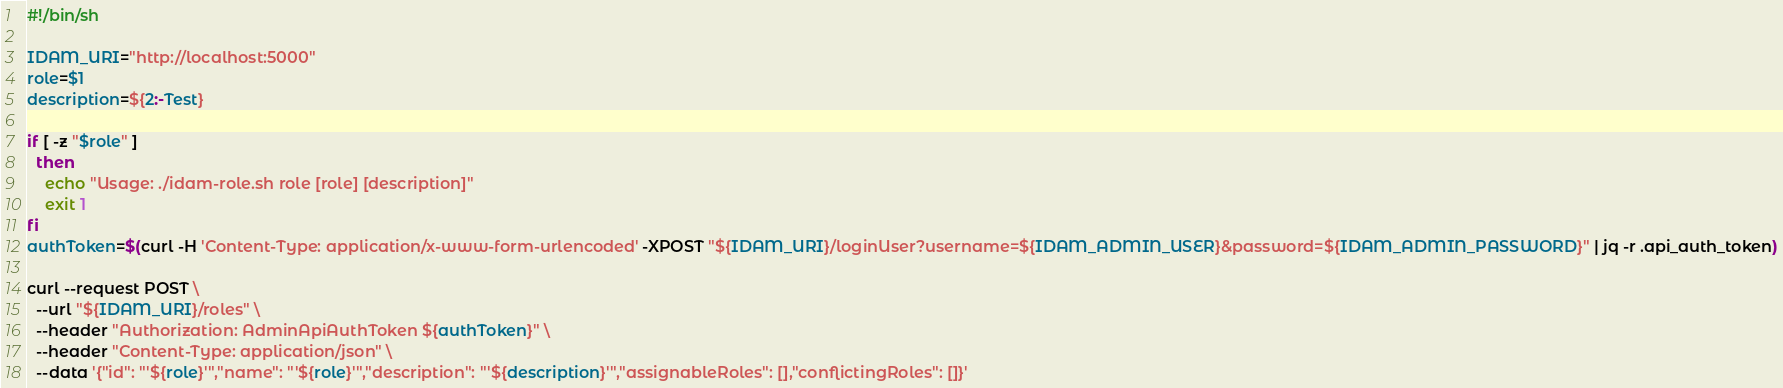Convert code to text. <code><loc_0><loc_0><loc_500><loc_500><_Bash_>#!/bin/sh

IDAM_URI="http://localhost:5000"
role=$1
description=${2:-Test}

if [ -z "$role" ]
  then
    echo "Usage: ./idam-role.sh role [role] [description]"
    exit 1
fi
authToken=$(curl -H 'Content-Type: application/x-www-form-urlencoded' -XPOST "${IDAM_URI}/loginUser?username=${IDAM_ADMIN_USER}&password=${IDAM_ADMIN_PASSWORD}" | jq -r .api_auth_token)

curl --request POST \
  --url "${IDAM_URI}/roles" \
  --header "Authorization: AdminApiAuthToken ${authToken}" \
  --header "Content-Type: application/json" \
  --data '{"id": "'${role}'","name": "'${role}'","description": "'${description}'","assignableRoles": [],"conflictingRoles": []}'
</code> 